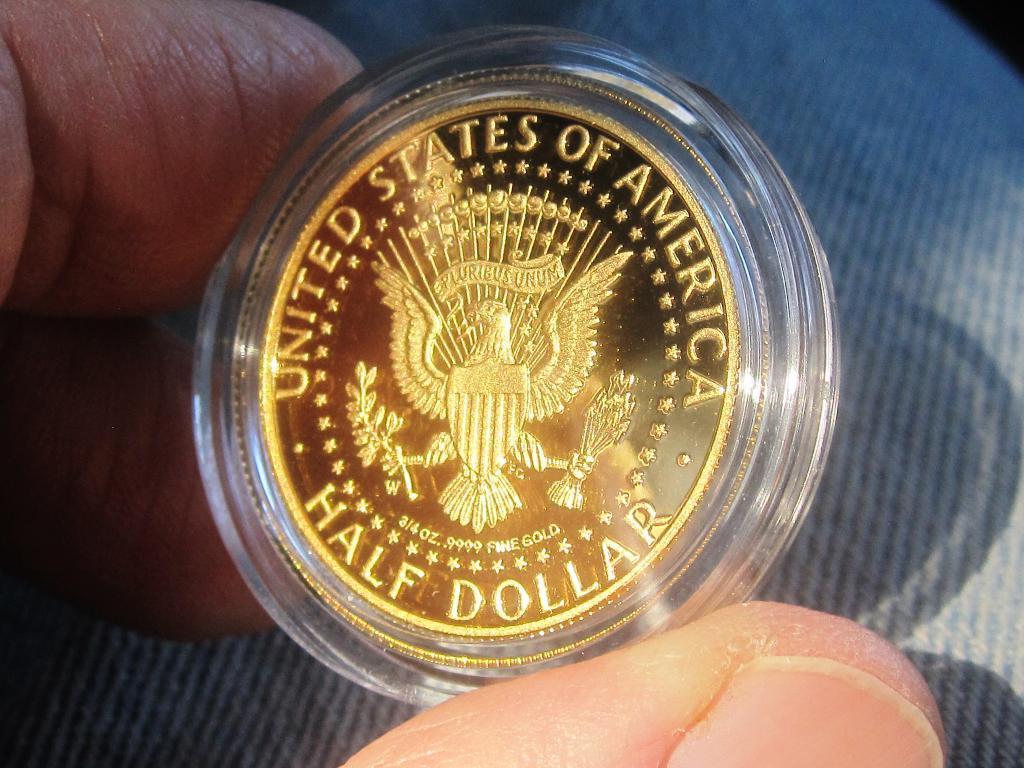How would you summarize this image in a sentence or two? In this picture, we see the hands of the person holding a coin. On the coin, it is written as " UNITED STATES OF AMERICA - HALF DOLLAR". In the background, we see a grey color carpet or a sheet. 